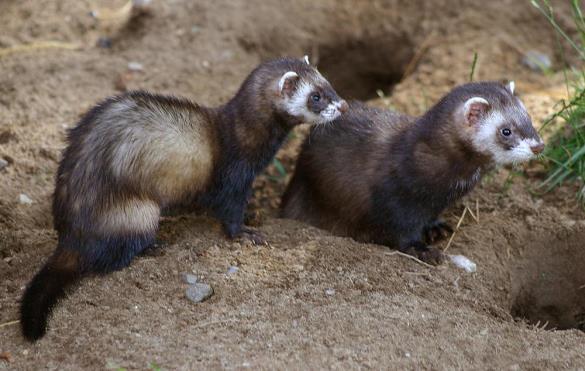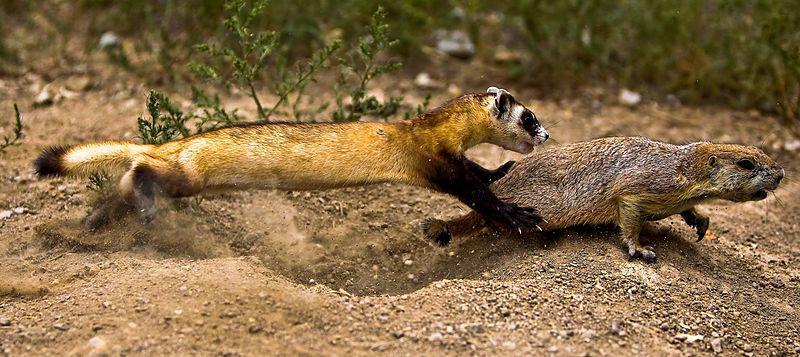The first image is the image on the left, the second image is the image on the right. Evaluate the accuracy of this statement regarding the images: "There is at least one ferret in a hole.". Is it true? Answer yes or no. No. The first image is the image on the left, the second image is the image on the right. For the images shown, is this caption "The left and right image contains the same number of small rodents." true? Answer yes or no. Yes. 